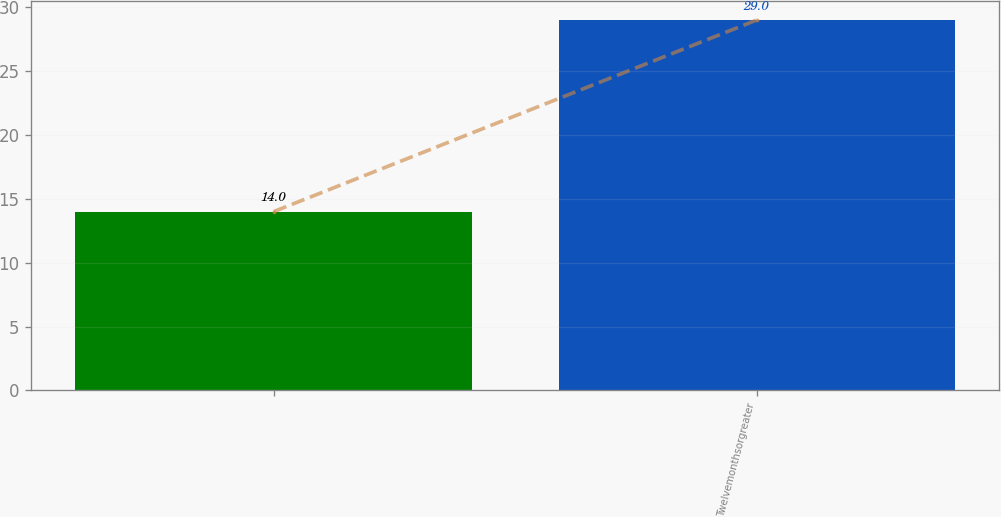Convert chart. <chart><loc_0><loc_0><loc_500><loc_500><bar_chart><ecel><fcel>Twelvemonthsorgreater<nl><fcel>14<fcel>29<nl></chart> 